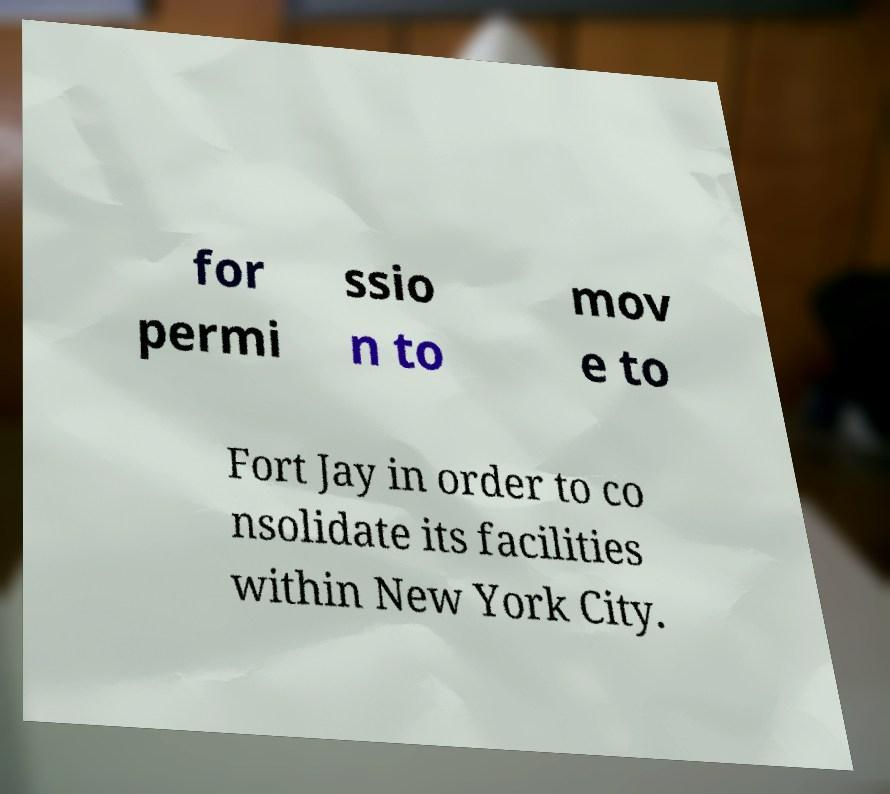I need the written content from this picture converted into text. Can you do that? for permi ssio n to mov e to Fort Jay in order to co nsolidate its facilities within New York City. 